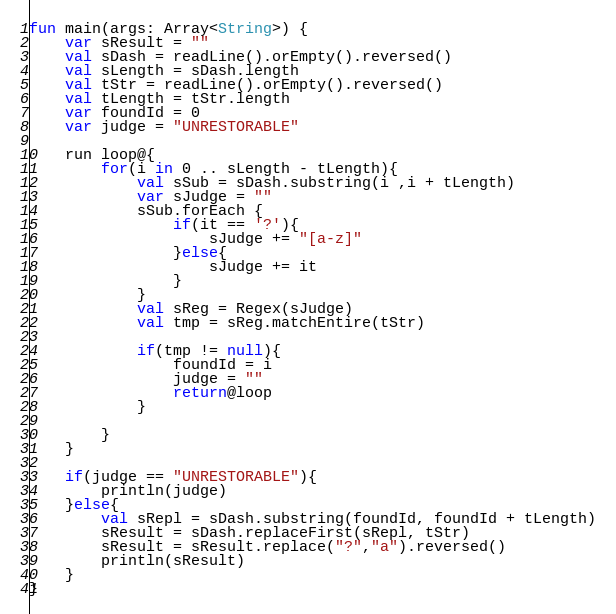<code> <loc_0><loc_0><loc_500><loc_500><_Kotlin_>fun main(args: Array<String>) {
    var sResult = ""
    val sDash = readLine().orEmpty().reversed()
    val sLength = sDash.length
    val tStr = readLine().orEmpty().reversed()
    val tLength = tStr.length
    var foundId = 0
    var judge = "UNRESTORABLE"

    run loop@{
        for(i in 0 .. sLength - tLength){
            val sSub = sDash.substring(i ,i + tLength)
            var sJudge = ""
            sSub.forEach {
                if(it == '?'){
                    sJudge += "[a-z]"
                }else{
                    sJudge += it
                }
            }
            val sReg = Regex(sJudge)
            val tmp = sReg.matchEntire(tStr)

            if(tmp != null){
                foundId = i
                judge = ""
                return@loop
            }

        }
    }

    if(judge == "UNRESTORABLE"){
        println(judge)
    }else{
        val sRepl = sDash.substring(foundId, foundId + tLength)
        sResult = sDash.replaceFirst(sRepl, tStr)
        sResult = sResult.replace("?","a").reversed()
        println(sResult)
    }
}</code> 